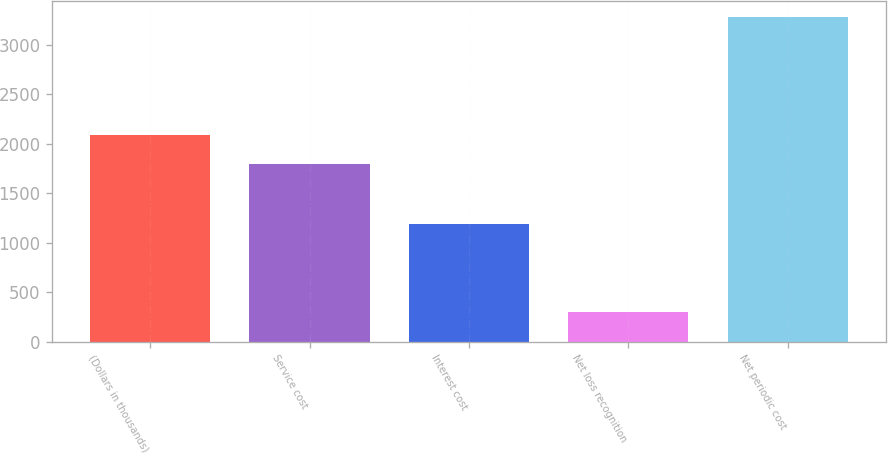Convert chart. <chart><loc_0><loc_0><loc_500><loc_500><bar_chart><fcel>(Dollars in thousands)<fcel>Service cost<fcel>Interest cost<fcel>Net loss recognition<fcel>Net periodic cost<nl><fcel>2092<fcel>1794<fcel>1187<fcel>300<fcel>3280<nl></chart> 